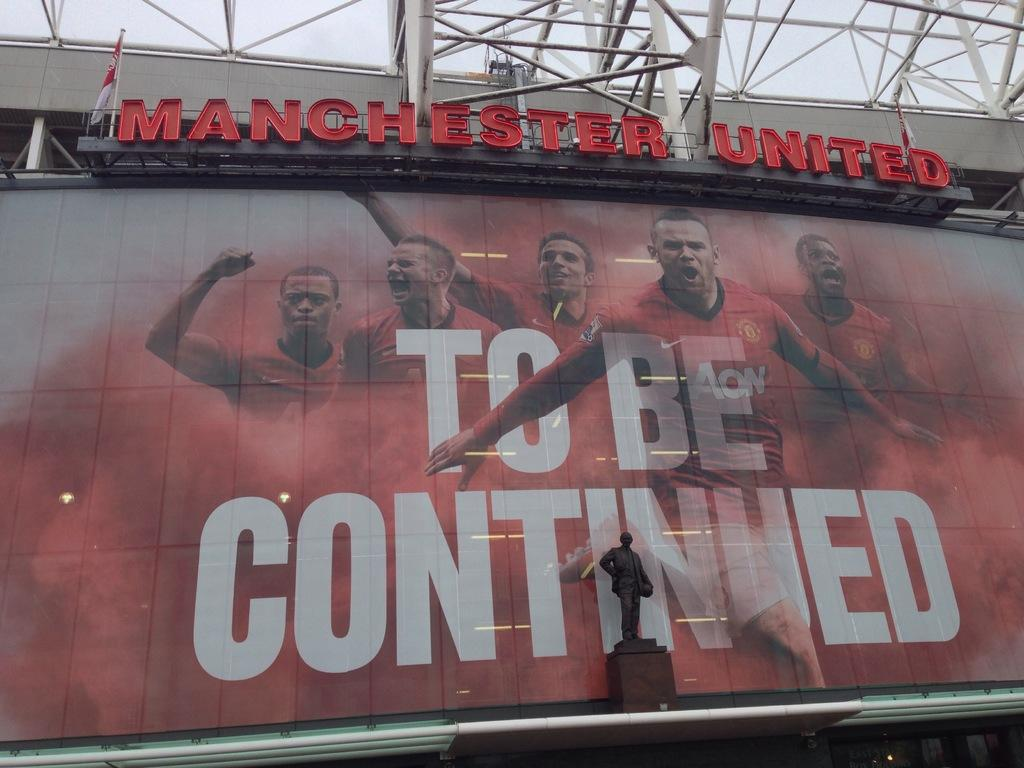<image>
Describe the image concisely. The outside of the Manchester United Arena with a To Be Continued sign out front. 